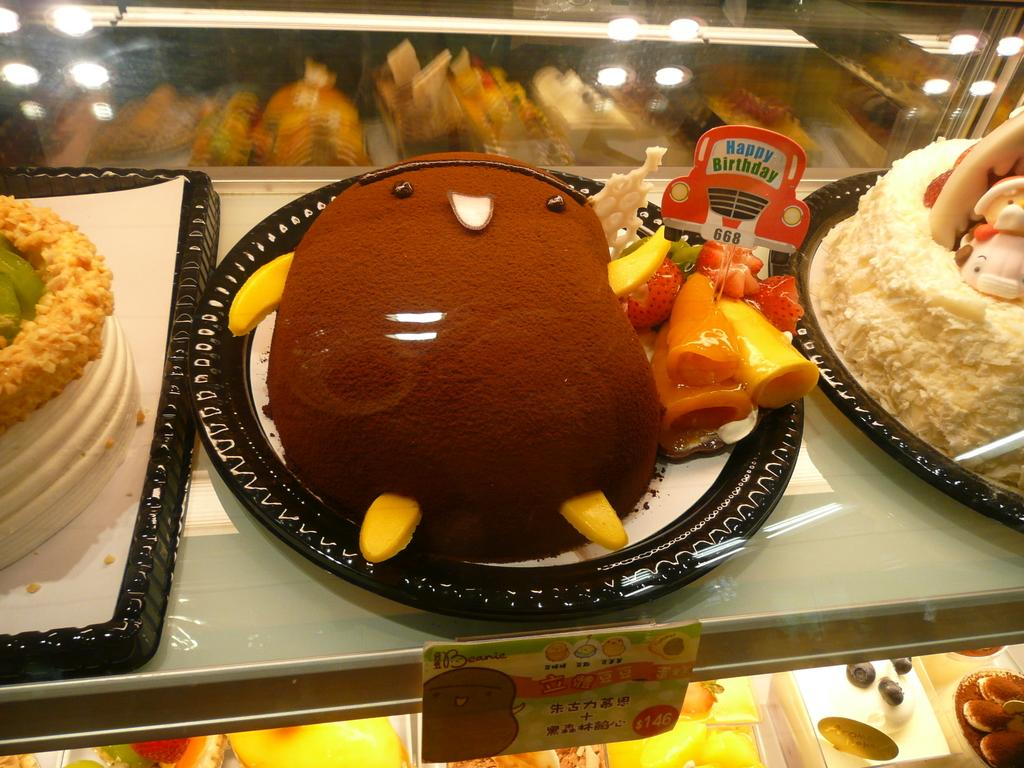What can be seen on the racks in the image? There are cakes on trays on the racks in the image. What is unique about the tags on the cakes? The tags on the cakes are in the shape of a car. Are there any tags on the rack itself? Yes, there is a tag on the rack. What type of property is being sold in the image? There is no property being sold in the image; it features racks with cakes on trays. What word is written on the tag on the rack? There is no word visible on the tag on the rack in the image. 